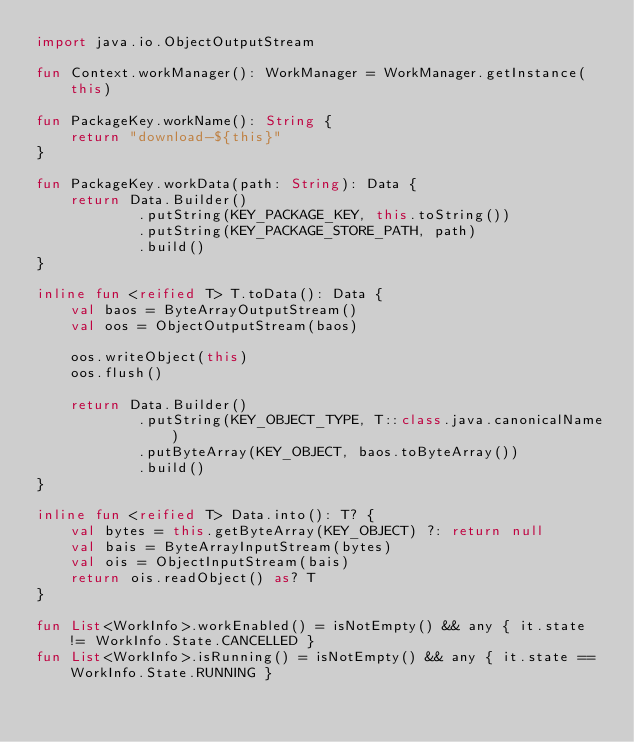<code> <loc_0><loc_0><loc_500><loc_500><_Kotlin_>import java.io.ObjectOutputStream

fun Context.workManager(): WorkManager = WorkManager.getInstance(this)

fun PackageKey.workName(): String {
    return "download-${this}"
}

fun PackageKey.workData(path: String): Data {
    return Data.Builder()
            .putString(KEY_PACKAGE_KEY, this.toString())
            .putString(KEY_PACKAGE_STORE_PATH, path)
            .build()
}

inline fun <reified T> T.toData(): Data {
    val baos = ByteArrayOutputStream()
    val oos = ObjectOutputStream(baos)

    oos.writeObject(this)
    oos.flush()

    return Data.Builder()
            .putString(KEY_OBJECT_TYPE, T::class.java.canonicalName)
            .putByteArray(KEY_OBJECT, baos.toByteArray())
            .build()
}

inline fun <reified T> Data.into(): T? {
    val bytes = this.getByteArray(KEY_OBJECT) ?: return null
    val bais = ByteArrayInputStream(bytes)
    val ois = ObjectInputStream(bais)
    return ois.readObject() as? T
}

fun List<WorkInfo>.workEnabled() = isNotEmpty() && any { it.state != WorkInfo.State.CANCELLED }
fun List<WorkInfo>.isRunning() = isNotEmpty() && any { it.state == WorkInfo.State.RUNNING }


</code> 